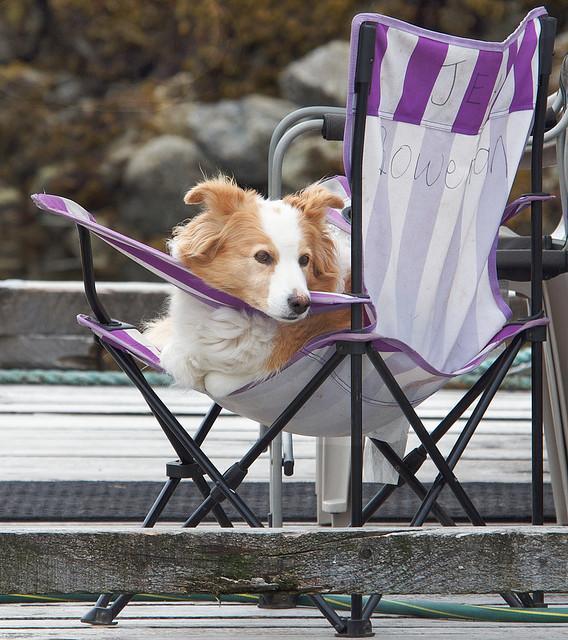How many brown cows are there?
Give a very brief answer. 0. 